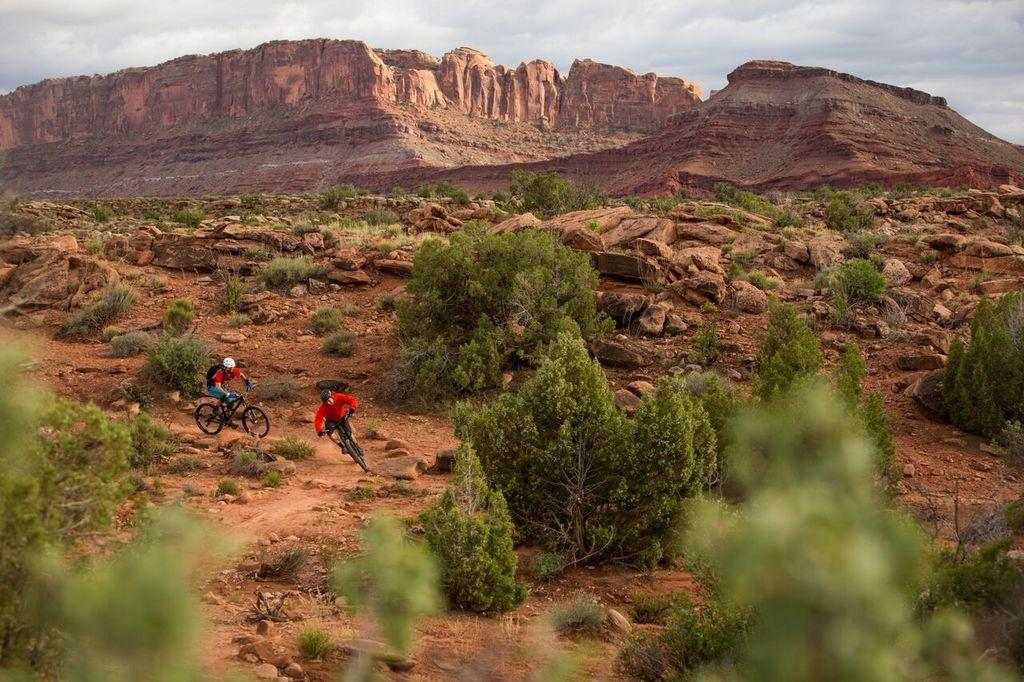How many people are in the image? There are two persons in the image. What are the persons wearing on their heads? The persons are wearing helmets. What are the persons doing in the image? The persons are riding cycles. What type of vegetation can be seen in the image? There are trees in the image. What type of terrain is visible in the image? There are stones and a hill in the image. What is visible in the background of the image? The sky is visible in the background of the image, and there are clouds in the sky. What type of food is being prepared on the low fire in the image? There is no food or fire present in the image; it features two persons riding cycles. What type of smoke can be seen coming from the hill in the image? There is no smoke visible in the image; it only shows a hill in the background. 